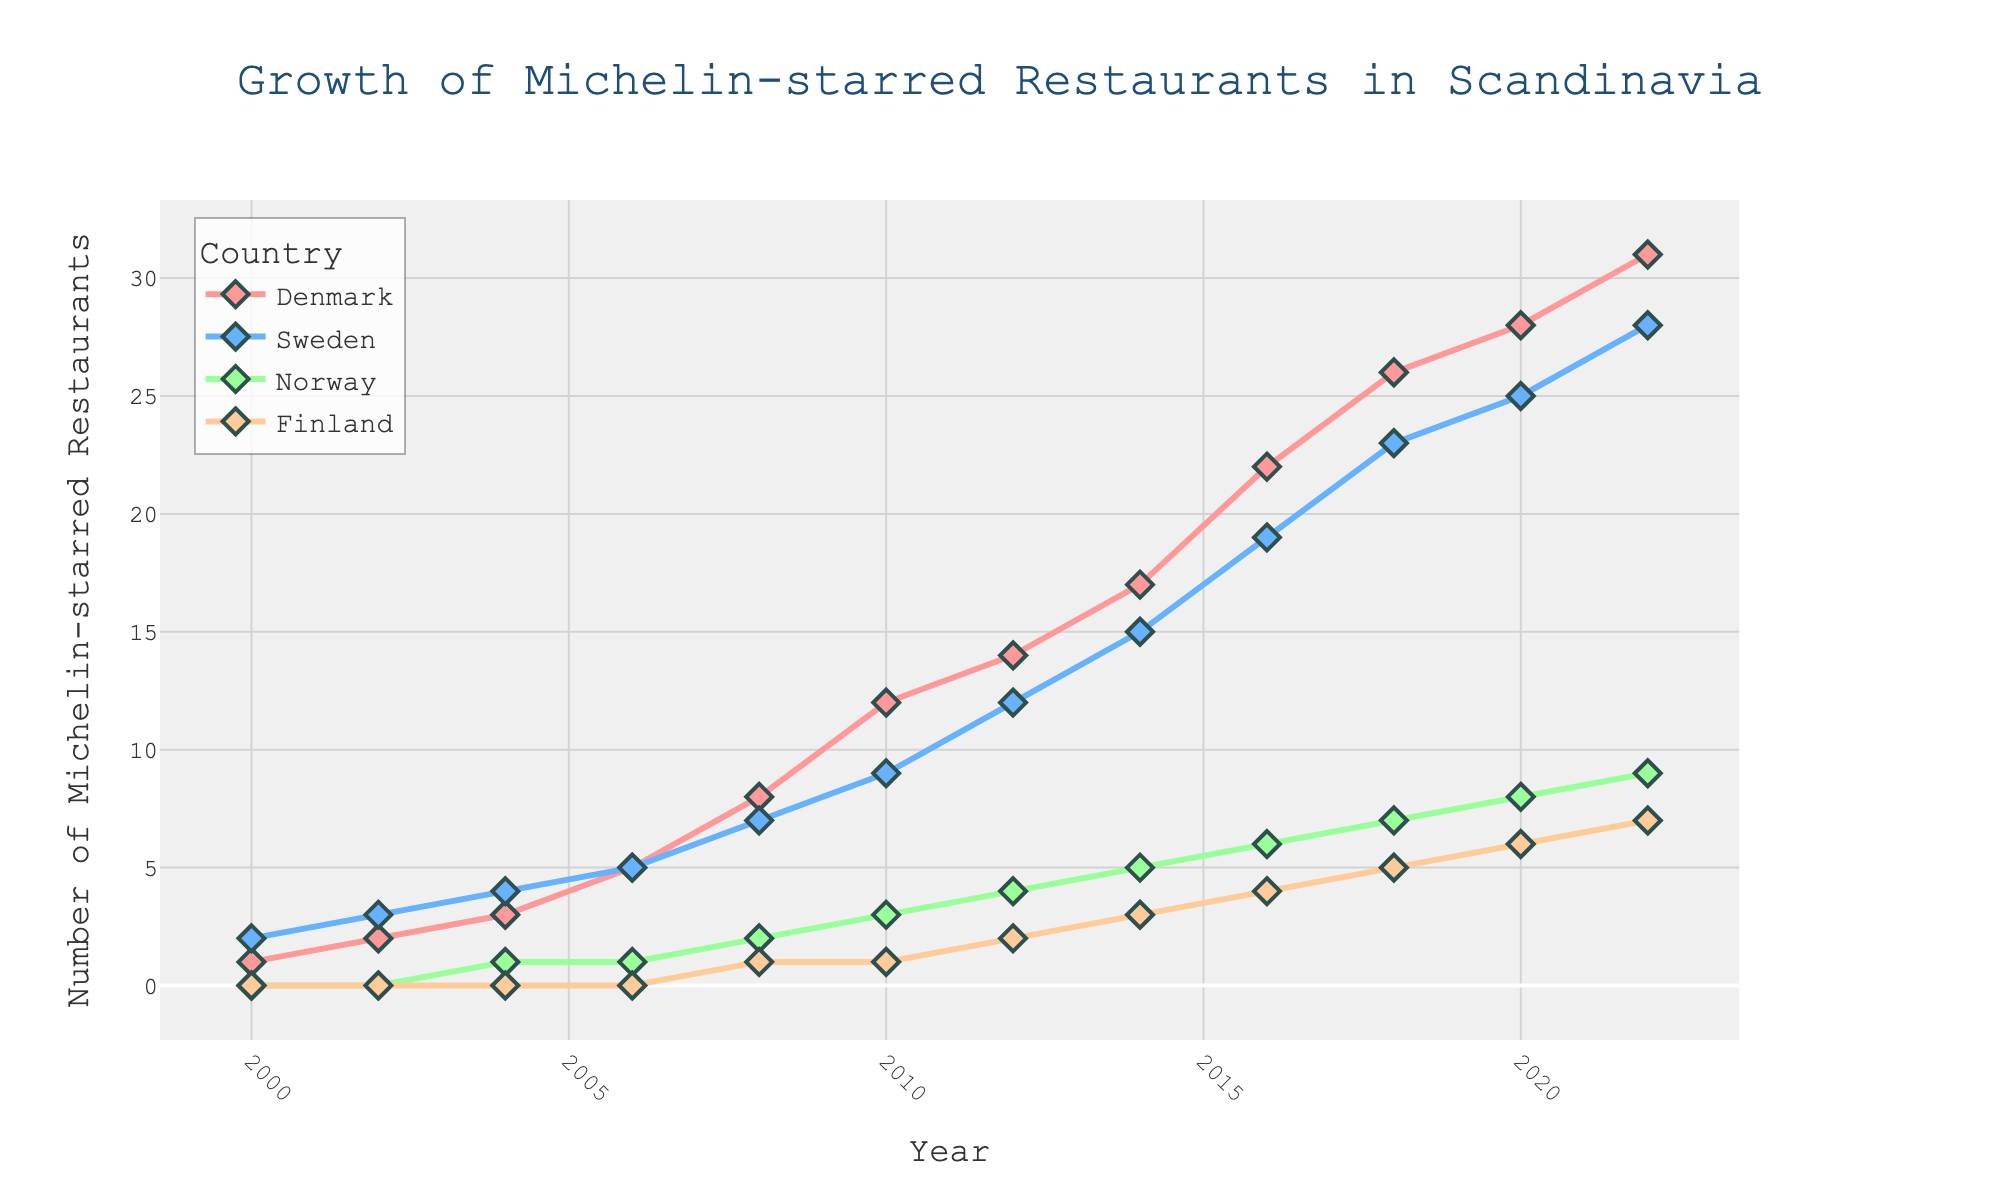What year did Denmark first surpass 20 Michelin-starred restaurants? Look for the point where the line for Denmark crosses the 20 mark on the y-axis. This happens in 2016 when Denmark's count reaches 22.
Answer: 2016 Which country had the slowest growth in Michelin-starred restaurants from 2000 to 2022? Identify the countries by their lines on the chart and compare their starting and ending points. Finland had the slowest growth, starting at 0 and ending at 7.
Answer: Finland In 2012, which country had the second-highest number of Michelin-starred restaurants? Look at the 2012 marker on the x-axis and compare the heights of the lines. Sweden had 12, second to Denmark's 14.
Answer: Sweden How many Michelin-starred restaurants were added in Denmark from 2008 to 2014? Subtract the number in 2008 (8) from the number in 2014 (17). So, 17 - 8 = 9 restaurants were added.
Answer: 9 Compare the growth trends of Norway and Finland. Which country had a steeper growth after 2010? Observe the slopes between 2010 and 2022 for both countries. Norway's line has a steeper slope compared to Finland's, indicating faster growth.
Answer: Norway What is the cumulative number of Michelin-starred restaurants in Scandinavia in 2020? Add the values for Denmark, Sweden, Norway, and Finland in 2020: 28 + 25 + 8 + 6 = 67.
Answer: 67 Visually, which country’s growth line has the most significant increase in steepness across the entire time period? Comparing the overall steepness of all lines, Denmark's line shows the most significant increase.
Answer: Denmark Between 2004 and 2008, which country showed the greatest increase in Michelin-starred restaurants? Subtract the 2004 values from the 2008 values for each country: Denmark (8-3=5), Sweden (7-4=3), Norway (2-1=1), and Finland (1-0=1). Denmark has the greatest increase.
Answer: Denmark Which two countries had the same number of Michelin-starred restaurants in any year? Find any crossing points or overlapping values. In 2016, Sweden (19) and Norway (6) have different values. Only Sweden and Finland had the same in 2022 at 7.
Answer: None 